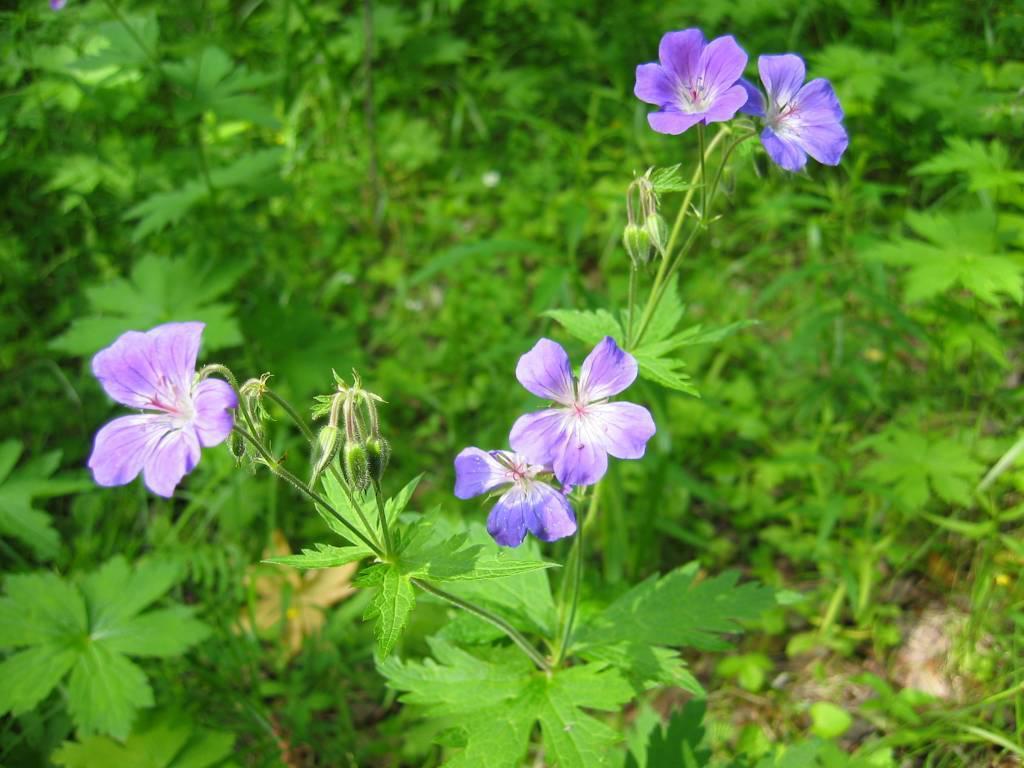How would you summarize this image in a sentence or two? In this image in the middle, there are plants, flowers, leaves. In the background there are plants, grass. 